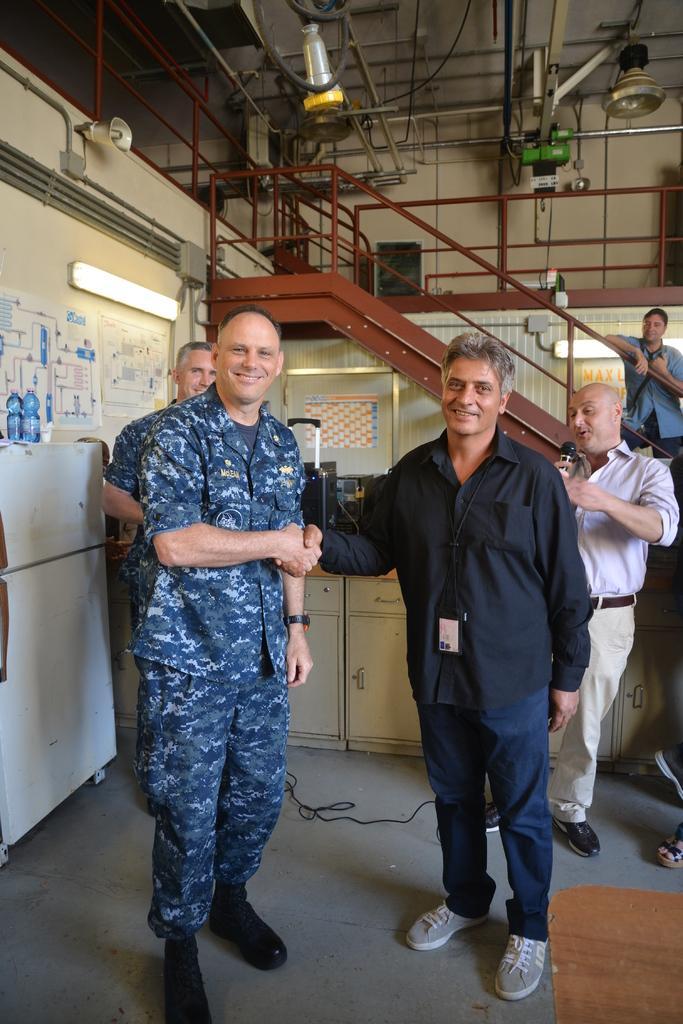Describe this image in one or two sentences. In this picture we can see tube lights, mic, cupboards, wire, fences, rods, bottles, posters and a group of people standing and smiling and in the background we can see some objects. 